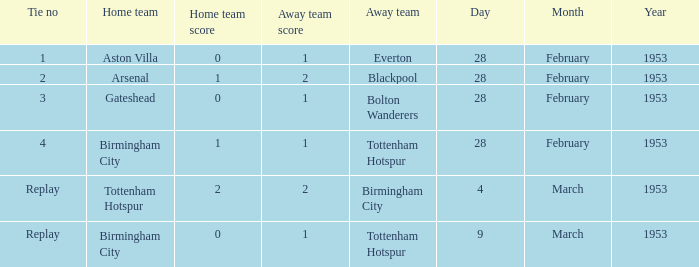Which home team holds a 0-1 score, and an away team of tottenham hotspur? Birmingham City. 